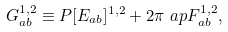<formula> <loc_0><loc_0><loc_500><loc_500>& \ G ^ { 1 , 2 } _ { a b } \equiv P [ E _ { a b } ] ^ { 1 , 2 } + 2 \pi \ a p F ^ { 1 , 2 } _ { a b } ,</formula> 